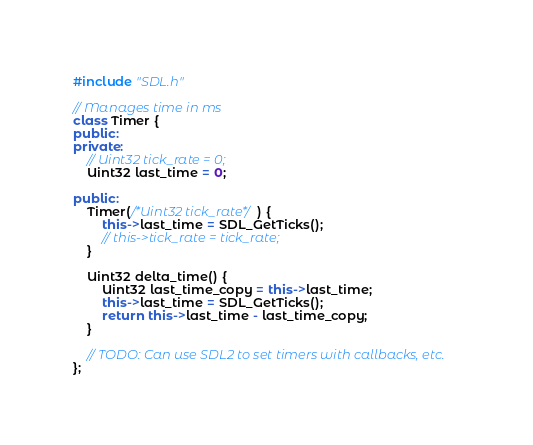Convert code to text. <code><loc_0><loc_0><loc_500><loc_500><_C++_>#include "SDL.h"

// Manages time in ms
class Timer {
public:
private:
    // Uint32 tick_rate = 0;
    Uint32 last_time = 0;

public:
    Timer(/*Uint32 tick_rate*/) {
        this->last_time = SDL_GetTicks();
        // this->tick_rate = tick_rate;
    }

    Uint32 delta_time() {
        Uint32 last_time_copy = this->last_time;
        this->last_time = SDL_GetTicks();
        return this->last_time - last_time_copy;
    }

    // TODO: Can use SDL2 to set timers with callbacks, etc.
};</code> 